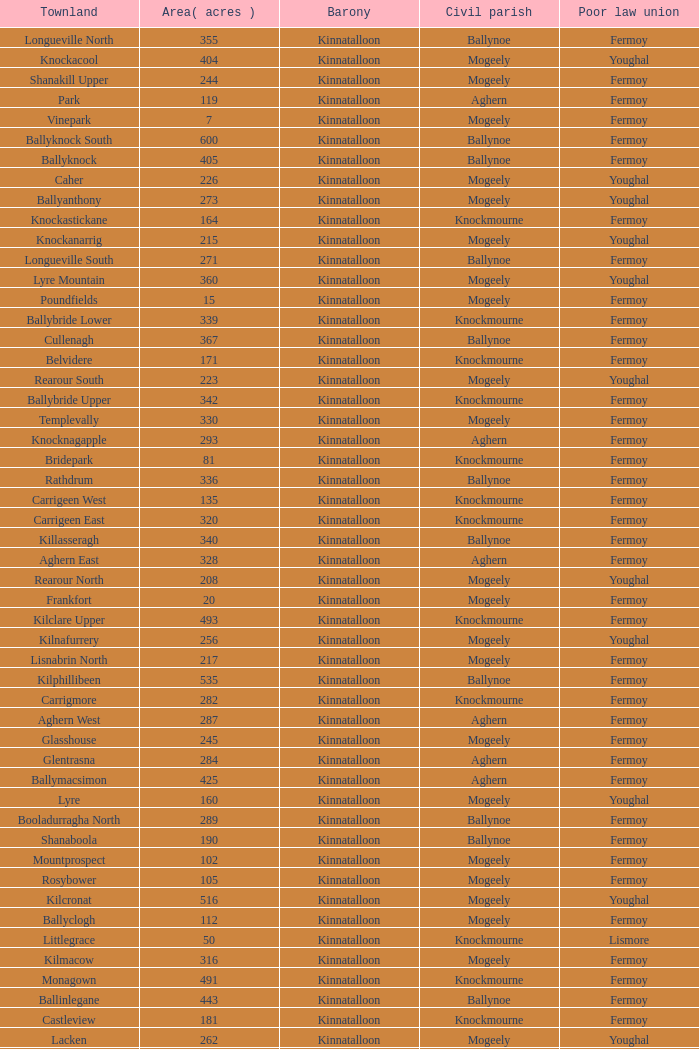What is the townland called for both fermoy and ballynoe? Ballinlegane, Ballinscurloge, Ballyknock, Ballyknock North, Ballyknock South, Ballymonteen, Ballynattin, Ballynoe, Booladurragha North, Booladurragha South, Cullenagh, Garraneribbeen, Glenreagh, Glentane, Killasseragh, Kilphillibeen, Knockakeo, Longueville North, Longueville South, Rathdrum, Shanaboola. 